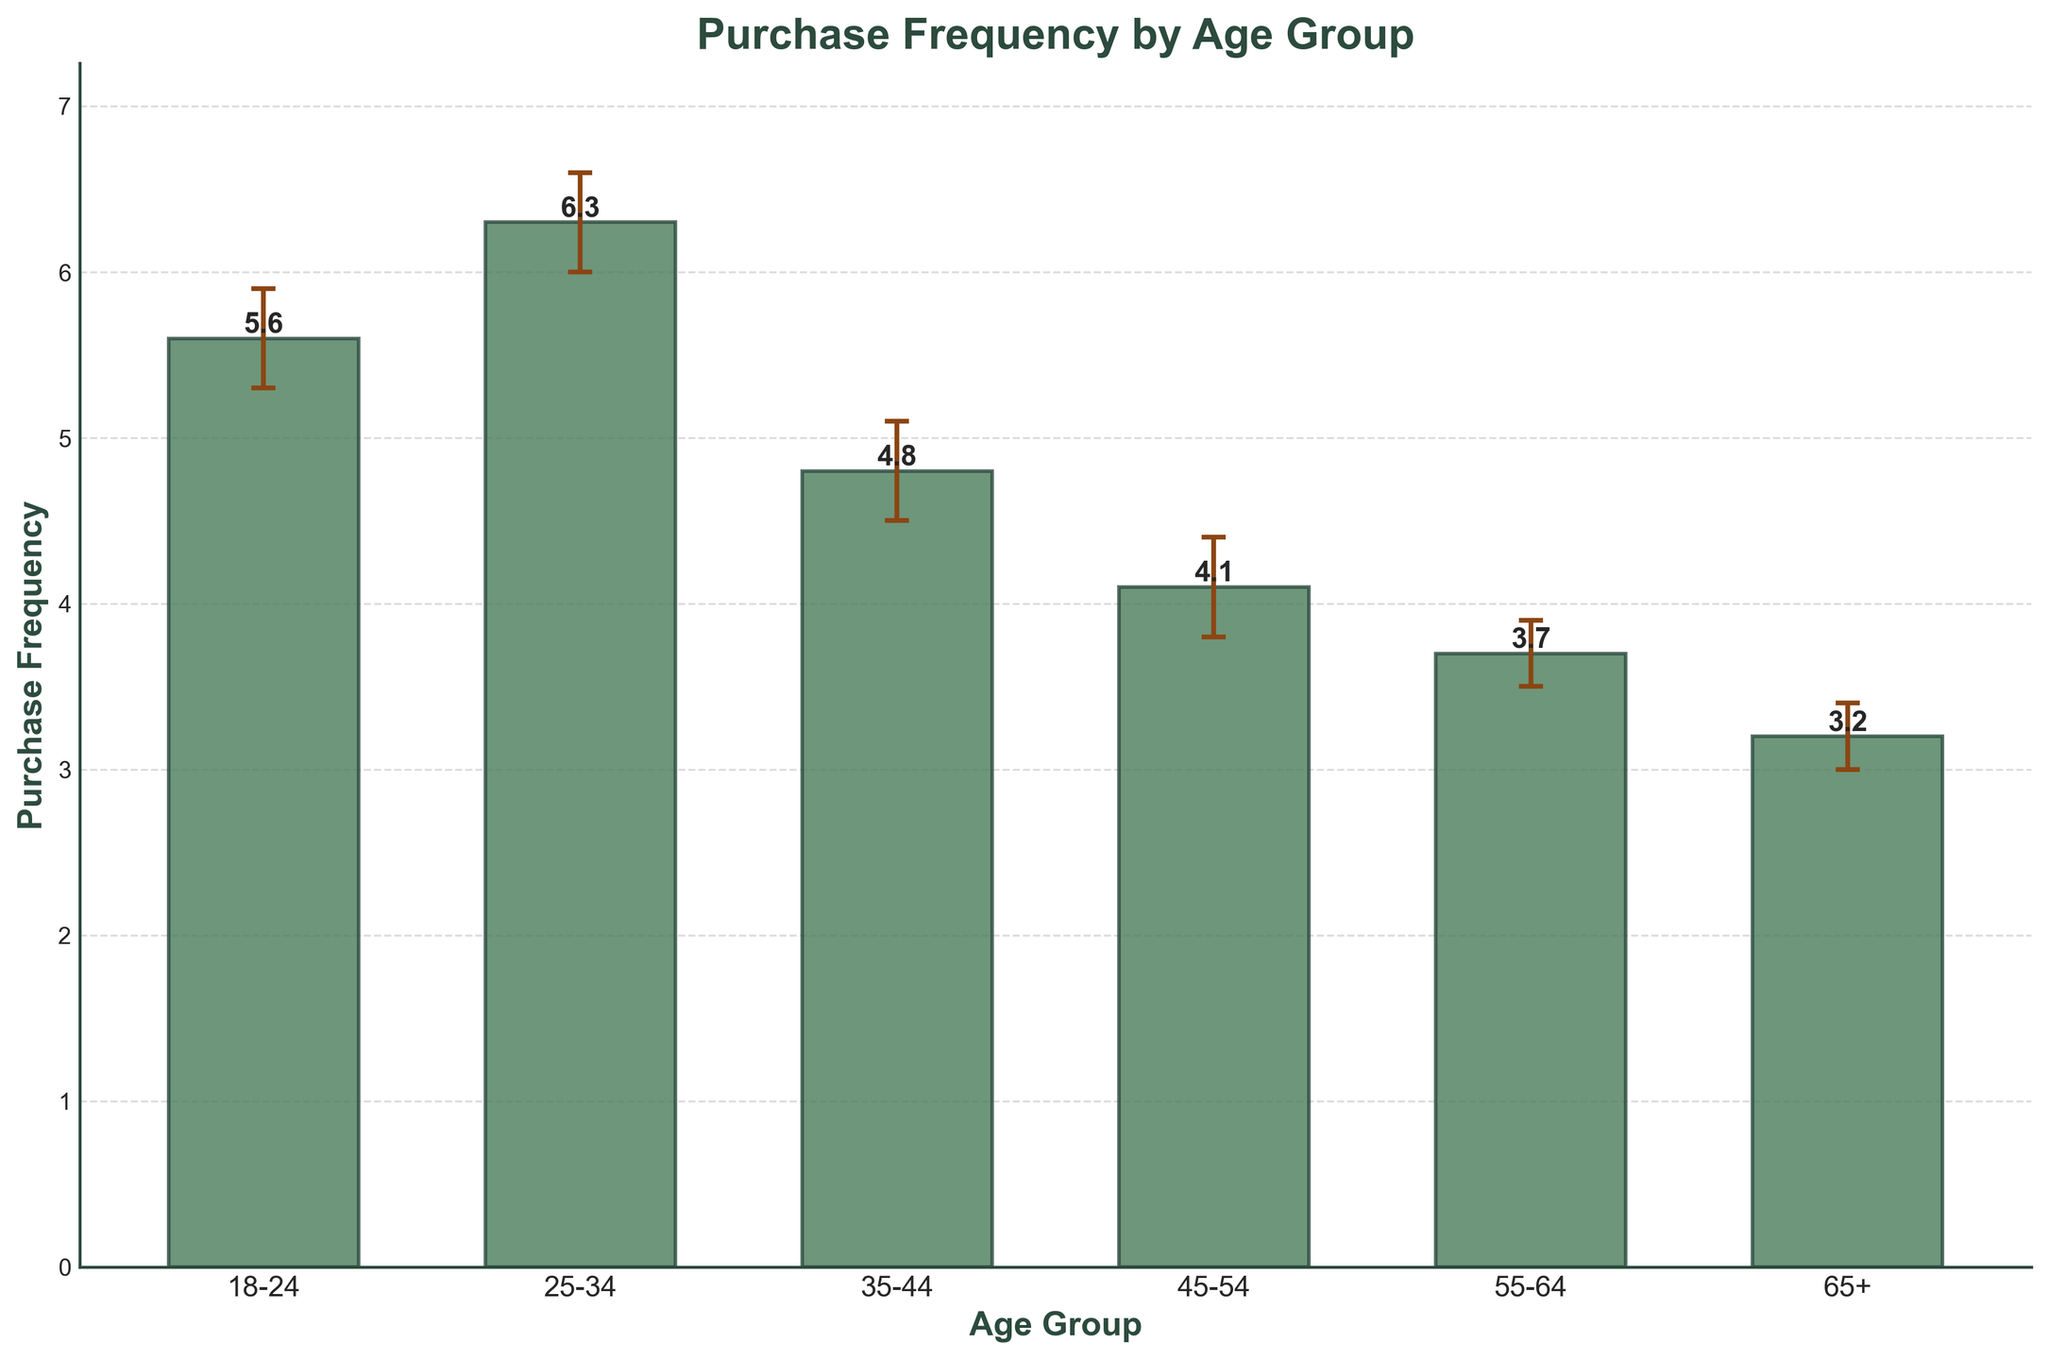What is the title of the chart? The title of the chart is displayed at the top and is clearly labeled.
Answer: Purchase Frequency by Age Group What is the purchase frequency for the 25-34 age group? Look at the height of the bar corresponding to the 25-34 age group.
Answer: 6.3 Which age group has the lowest purchase frequency? By comparing the heights of all the bars, identify the one with the smallest value.
Answer: 65+ How do the confidence intervals for the 35-44 age group compare to those for the 45-54 age group? Compare the range of the error bars for both age groups: 35-44 (4.5 to 5.1) and 45-54 (3.8 to 4.4).
Answer: The ranges are equal, both 0.6 wide What is the difference in purchase frequency between the 18-24 and 65+ age groups? Subtract the purchase frequency of the 65+ age group from that of the 18-24 age group: 5.6 - 3.2.
Answer: 2.4 What is the midpoint of the confidence interval for the 55-64 age group? The midpoint is the average of the confidence interval lower and upper bounds: (3.5 + 3.9) / 2.
Answer: 3.7 What is the overall trend observed across the age groups? By observing the heights of the bars from the youngest to the oldest age groups, note the general direction of change.
Answer: Decreasing Which age group has the largest confidence interval size? Determine the differences between the upper and lower bounds for each age group and identify the largest: 45-54 and 35-44 both have 0.6.
Answer: 35-44, 45-54 How are the confidence intervals represented on the chart? Identify the visual means by which the confidence intervals are shown (error bars above and below the bars).
Answer: Error bars Are the purchase frequencies for the 35-44 and 45-54 age groups significantly different? Compare the purchase frequencies and their confidence intervals to see if they overlap: 35-44 (4.5 to 5.1) and 45-54 (3.8 to 4.4).
Answer: No, they overlap 